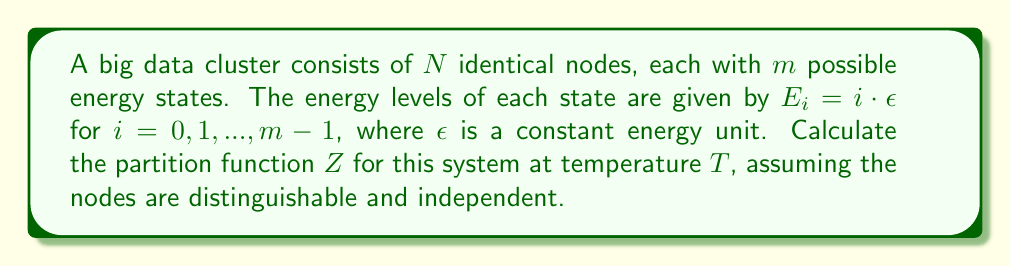Solve this math problem. To calculate the partition function for this system, we'll follow these steps:

1) The partition function for a single node is given by:

   $$Z_1 = \sum_{i=0}^{m-1} e^{-\beta E_i}$$

   where $\beta = \frac{1}{k_B T}$, $k_B$ is Boltzmann's constant, and $T$ is the temperature.

2) Substituting $E_i = i \cdot \epsilon$:

   $$Z_1 = \sum_{i=0}^{m-1} e^{-\beta i \epsilon}$$

3) This is a geometric series with $m$ terms, where the first term is 1 and the common ratio is $e^{-\beta \epsilon}$. The sum of such a series is given by:

   $$Z_1 = \frac{1 - e^{-\beta m \epsilon}}{1 - e^{-\beta \epsilon}}$$

4) Since the nodes are distinguishable and independent, the total partition function for $N$ nodes is the product of individual partition functions:

   $$Z = (Z_1)^N = \left(\frac{1 - e^{-\beta m \epsilon}}{1 - e^{-\beta \epsilon}}\right)^N$$

5) This can be written in a more compact form using the definition of $\beta$:

   $$Z = \left(\frac{1 - e^{-\frac{m \epsilon}{k_B T}}}{1 - e^{-\frac{\epsilon}{k_B T}}}\right)^N$$

This is the partition function for the entire big data cluster.
Answer: $$Z = \left(\frac{1 - e^{-\frac{m \epsilon}{k_B T}}}{1 - e^{-\frac{\epsilon}{k_B T}}}\right)^N$$ 